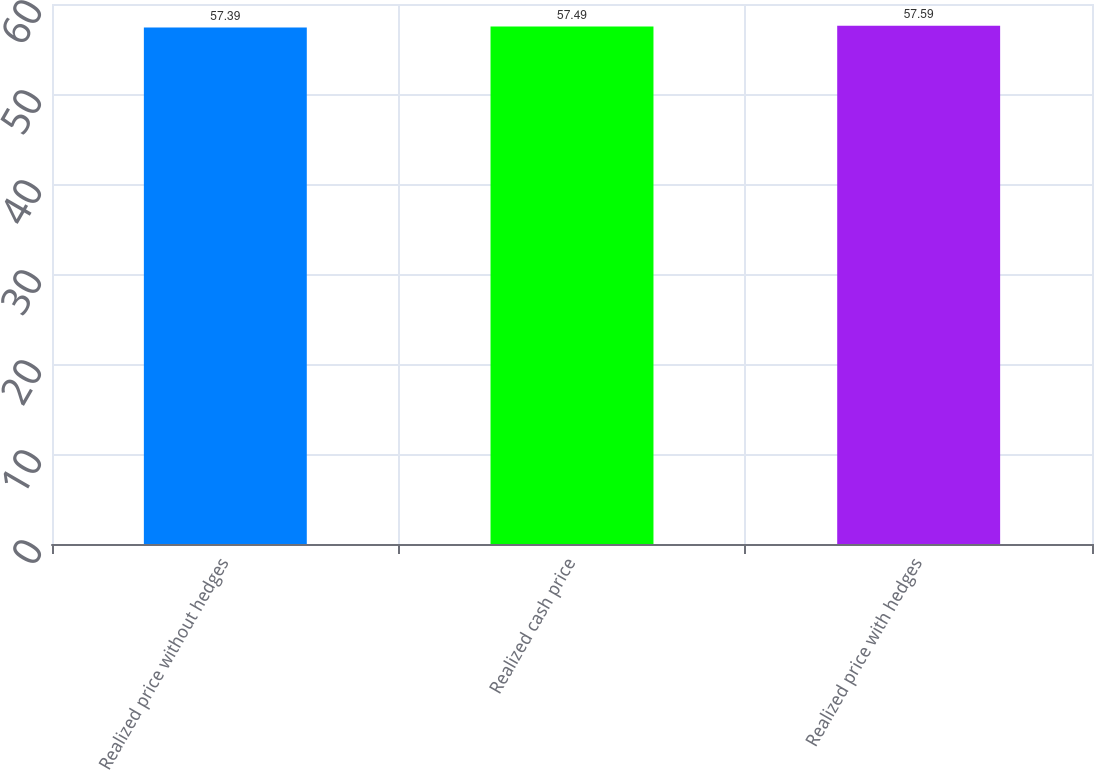Convert chart. <chart><loc_0><loc_0><loc_500><loc_500><bar_chart><fcel>Realized price without hedges<fcel>Realized cash price<fcel>Realized price with hedges<nl><fcel>57.39<fcel>57.49<fcel>57.59<nl></chart> 